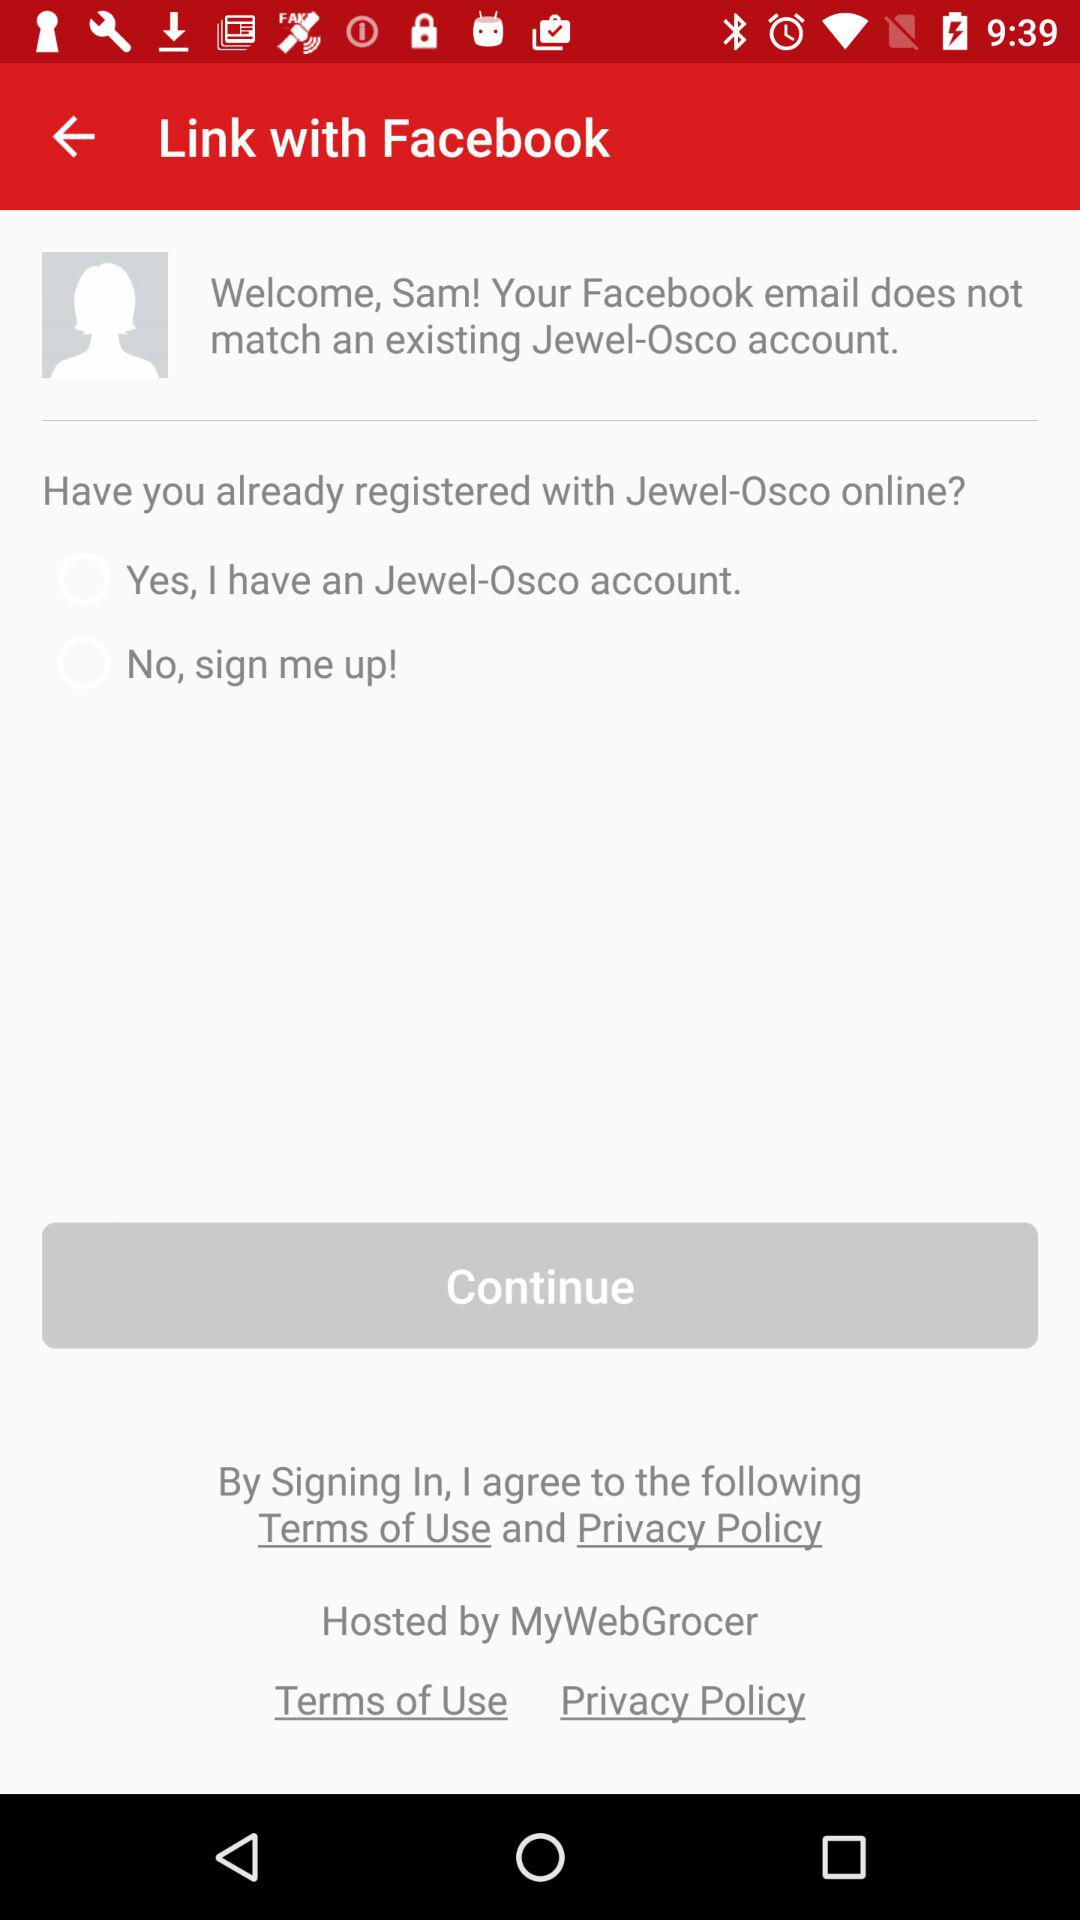What is the status of "Yes, I have an Jewel-Osco account"? The status is "off". 